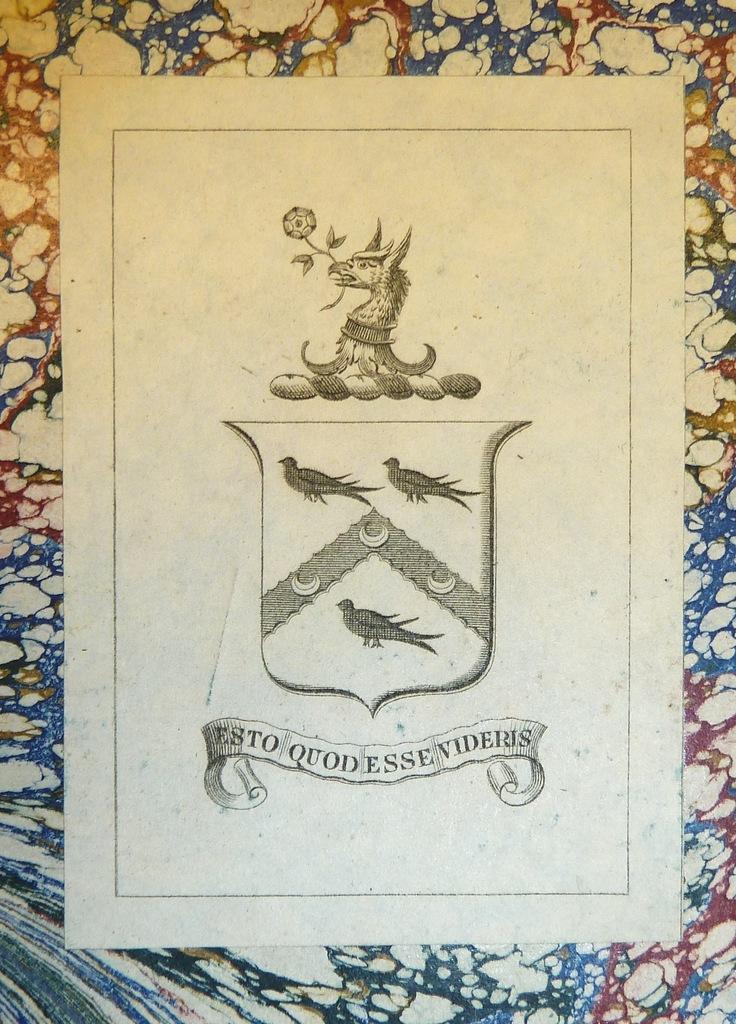How would you summarize this image in a sentence or two? In this picture there are pictures of the birds and there is text. At the back there is a multiple colors background. 